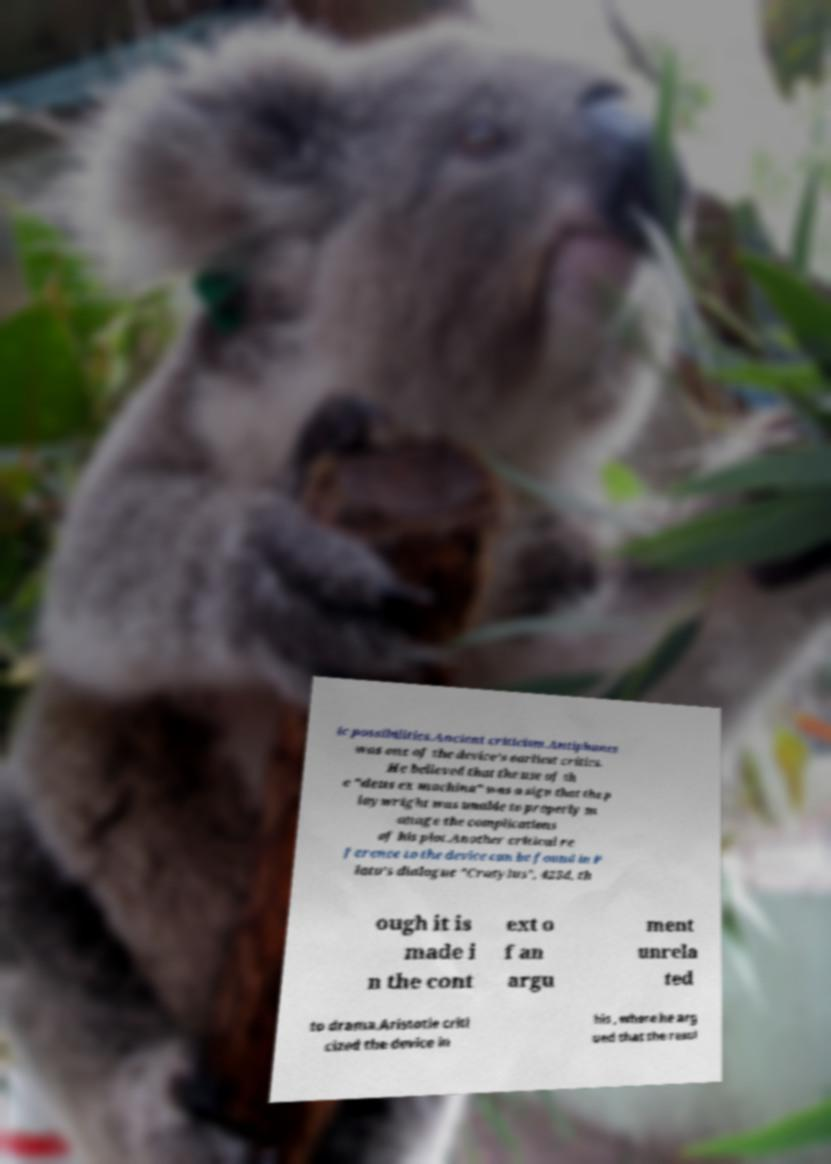Please identify and transcribe the text found in this image. ic possibilities.Ancient criticism.Antiphanes was one of the device's earliest critics. He believed that the use of th e "deus ex machina" was a sign that the p laywright was unable to properly m anage the complications of his plot.Another critical re ference to the device can be found in P lato's dialogue "Cratylus", 425d, th ough it is made i n the cont ext o f an argu ment unrela ted to drama.Aristotle criti cized the device in his , where he arg ued that the resol 